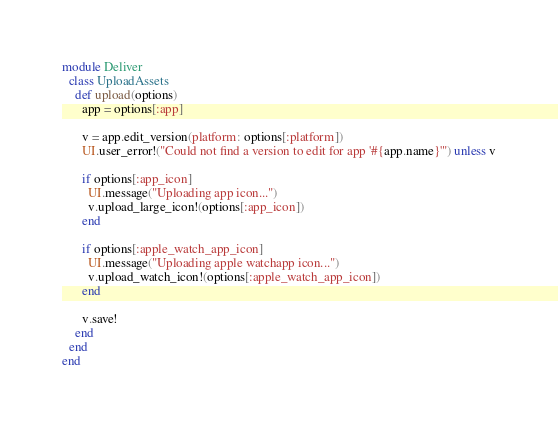Convert code to text. <code><loc_0><loc_0><loc_500><loc_500><_Ruby_>module Deliver
  class UploadAssets
    def upload(options)
      app = options[:app]

      v = app.edit_version(platform: options[:platform])
      UI.user_error!("Could not find a version to edit for app '#{app.name}'") unless v

      if options[:app_icon]
        UI.message("Uploading app icon...")
        v.upload_large_icon!(options[:app_icon])
      end

      if options[:apple_watch_app_icon]
        UI.message("Uploading apple watchapp icon...")
        v.upload_watch_icon!(options[:apple_watch_app_icon])
      end

      v.save!
    end
  end
end
</code> 